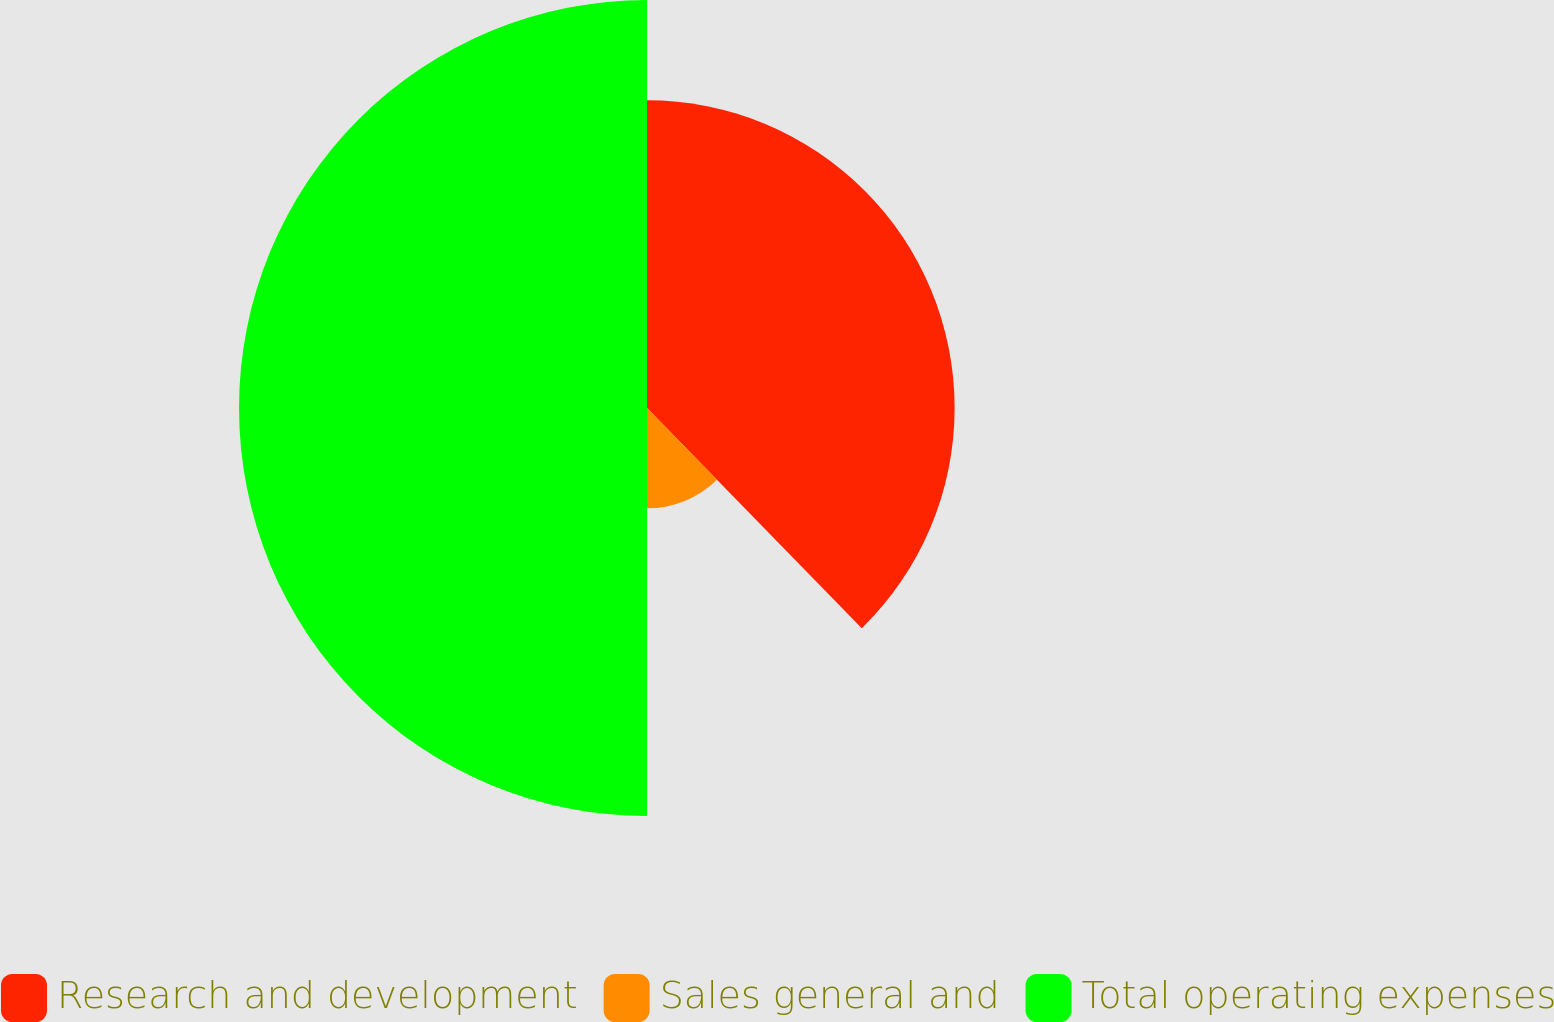Convert chart to OTSL. <chart><loc_0><loc_0><loc_500><loc_500><pie_chart><fcel>Research and development<fcel>Sales general and<fcel>Total operating expenses<nl><fcel>37.7%<fcel>12.3%<fcel>50.0%<nl></chart> 